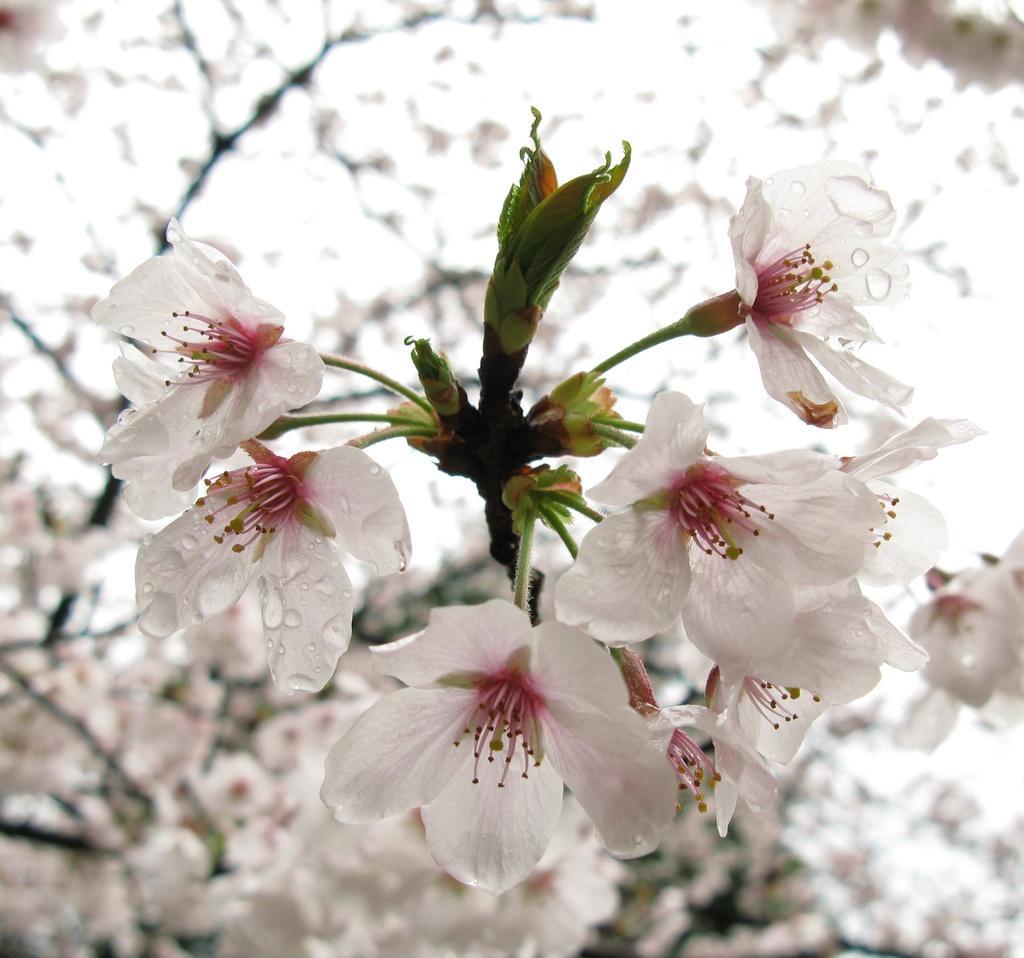Describe this image in one or two sentences. In this image we can see some flowers and the background is blurred. 